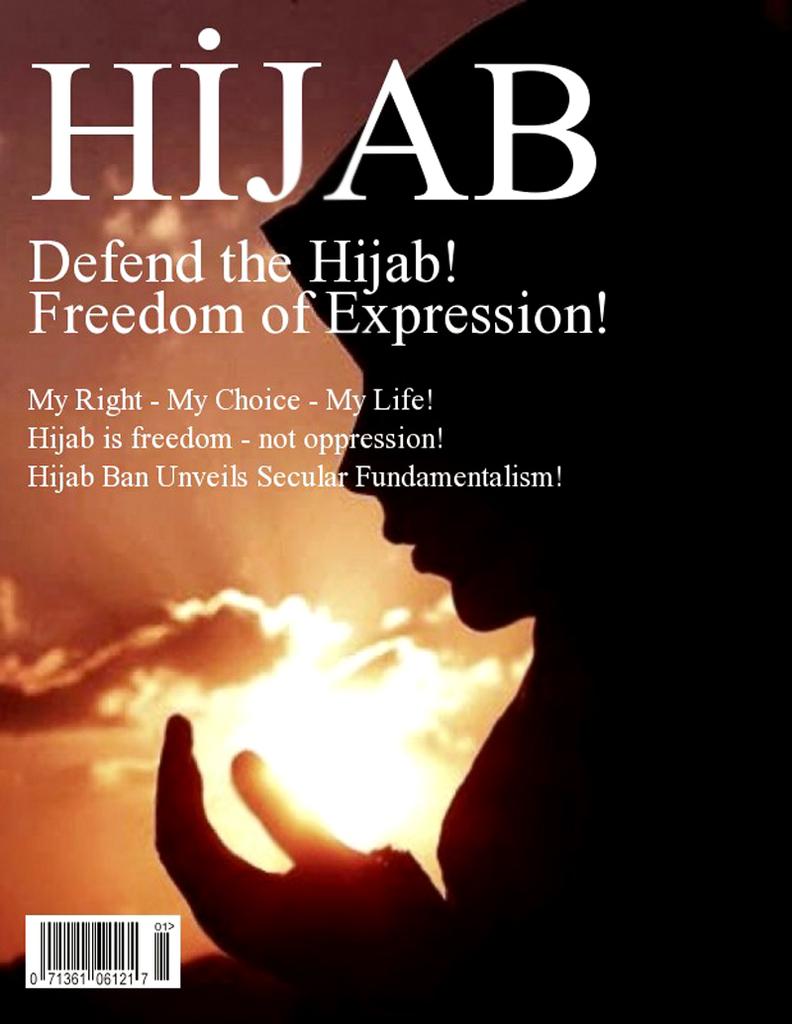What is this magazine asking you to defend?
Your response must be concise. The hijab. Who, "unveils secular fundamentalism"?
Provide a short and direct response. Hijab ban. 